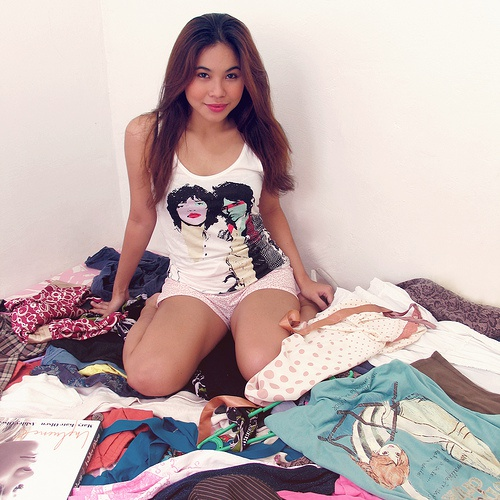Describe the objects in this image and their specific colors. I can see bed in white, darkgray, black, and brown tones, people in white, brown, lightgray, salmon, and black tones, and book in white, pink, darkgray, and purple tones in this image. 